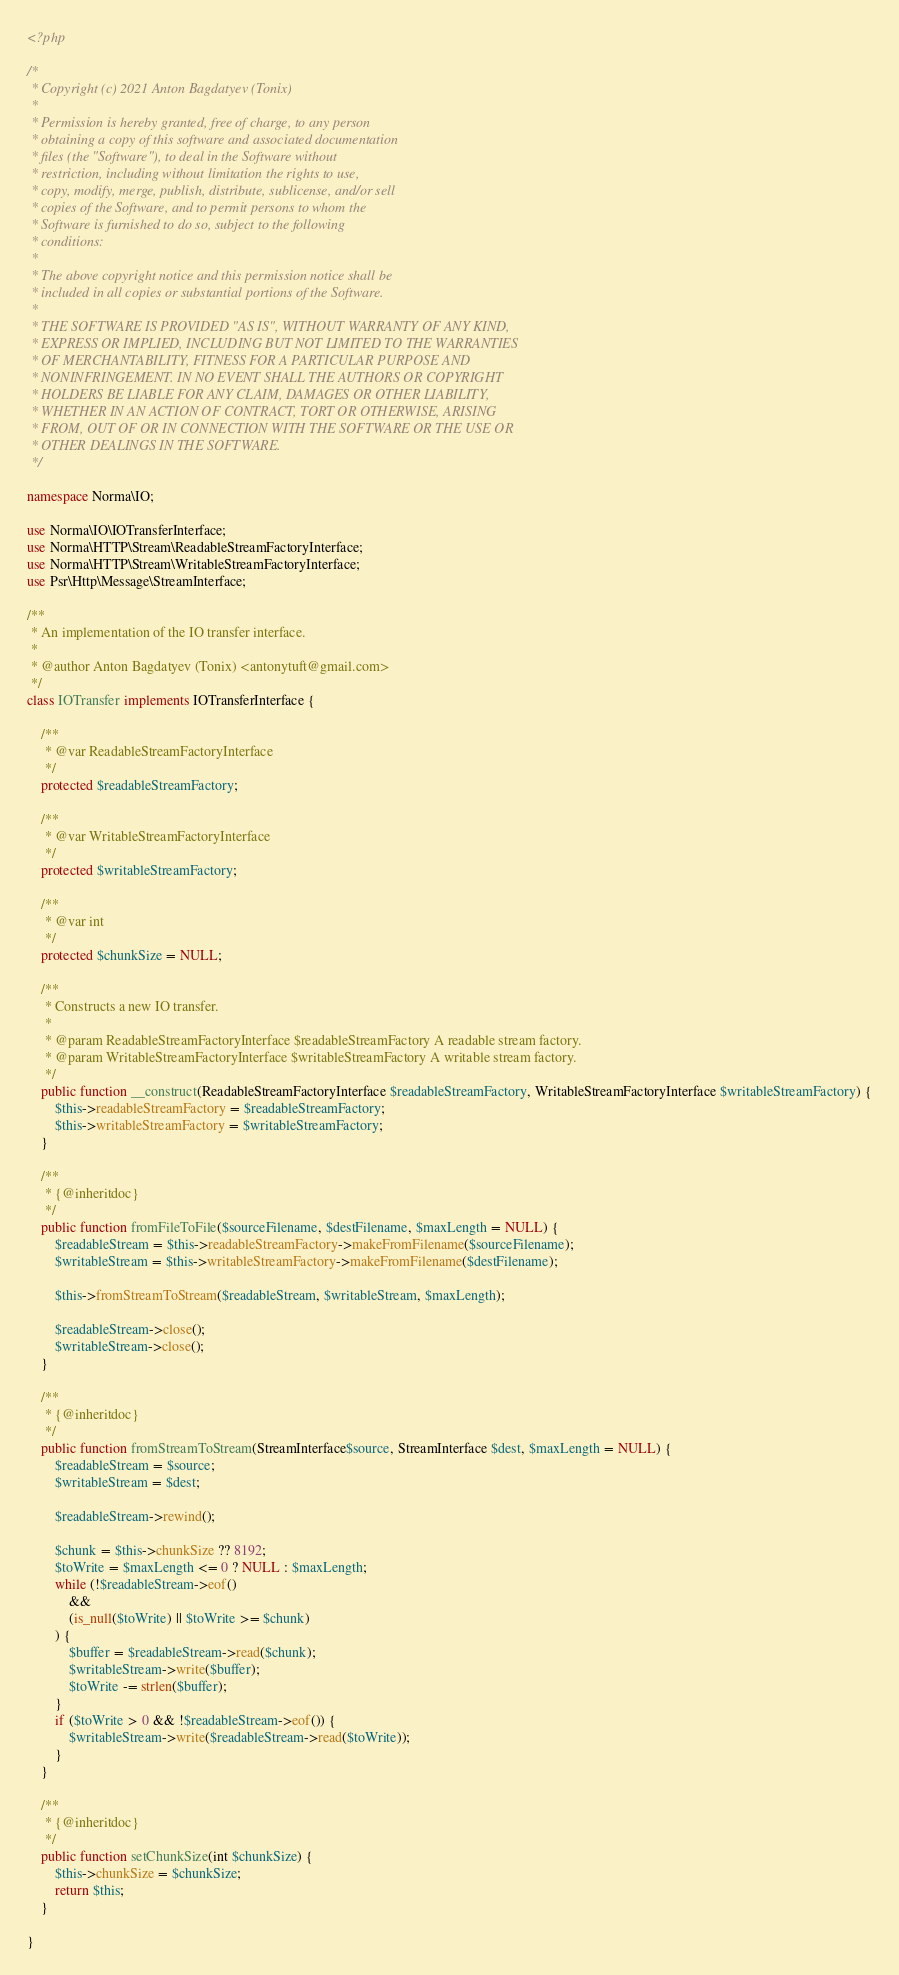<code> <loc_0><loc_0><loc_500><loc_500><_PHP_><?php

/*
 * Copyright (c) 2021 Anton Bagdatyev (Tonix)
 * 
 * Permission is hereby granted, free of charge, to any person
 * obtaining a copy of this software and associated documentation
 * files (the "Software"), to deal in the Software without
 * restriction, including without limitation the rights to use,
 * copy, modify, merge, publish, distribute, sublicense, and/or sell
 * copies of the Software, and to permit persons to whom the
 * Software is furnished to do so, subject to the following
 * conditions:
 * 
 * The above copyright notice and this permission notice shall be
 * included in all copies or substantial portions of the Software.
 * 
 * THE SOFTWARE IS PROVIDED "AS IS", WITHOUT WARRANTY OF ANY KIND,
 * EXPRESS OR IMPLIED, INCLUDING BUT NOT LIMITED TO THE WARRANTIES
 * OF MERCHANTABILITY, FITNESS FOR A PARTICULAR PURPOSE AND
 * NONINFRINGEMENT. IN NO EVENT SHALL THE AUTHORS OR COPYRIGHT
 * HOLDERS BE LIABLE FOR ANY CLAIM, DAMAGES OR OTHER LIABILITY,
 * WHETHER IN AN ACTION OF CONTRACT, TORT OR OTHERWISE, ARISING
 * FROM, OUT OF OR IN CONNECTION WITH THE SOFTWARE OR THE USE OR
 * OTHER DEALINGS IN THE SOFTWARE.
 */

namespace Norma\IO;

use Norma\IO\IOTransferInterface;
use Norma\HTTP\Stream\ReadableStreamFactoryInterface;
use Norma\HTTP\Stream\WritableStreamFactoryInterface;
use Psr\Http\Message\StreamInterface;

/**
 * An implementation of the IO transfer interface.
 *
 * @author Anton Bagdatyev (Tonix) <antonytuft@gmail.com>
 */
class IOTransfer implements IOTransferInterface {
    
    /**
     * @var ReadableStreamFactoryInterface
     */
    protected $readableStreamFactory;
    
    /**
     * @var WritableStreamFactoryInterface
     */
    protected $writableStreamFactory;
    
    /**
     * @var int
     */
    protected $chunkSize = NULL;
    
    /**
     * Constructs a new IO transfer.
     * 
     * @param ReadableStreamFactoryInterface $readableStreamFactory A readable stream factory.
     * @param WritableStreamFactoryInterface $writableStreamFactory A writable stream factory.
     */
    public function __construct(ReadableStreamFactoryInterface $readableStreamFactory, WritableStreamFactoryInterface $writableStreamFactory) {
        $this->readableStreamFactory = $readableStreamFactory;
        $this->writableStreamFactory = $writableStreamFactory;
    }
    
    /**
     * {@inheritdoc}
     */
    public function fromFileToFile($sourceFilename, $destFilename, $maxLength = NULL) {
        $readableStream = $this->readableStreamFactory->makeFromFilename($sourceFilename);
        $writableStream = $this->writableStreamFactory->makeFromFilename($destFilename);
        
        $this->fromStreamToStream($readableStream, $writableStream, $maxLength);
        
        $readableStream->close();
        $writableStream->close();
    }

    /**
     * {@inheritdoc}
     */
    public function fromStreamToStream(StreamInterface$source, StreamInterface $dest, $maxLength = NULL) {
        $readableStream = $source;
        $writableStream = $dest;
        
        $readableStream->rewind();
        
        $chunk = $this->chunkSize ?? 8192;
        $toWrite = $maxLength <= 0 ? NULL : $maxLength;
        while (!$readableStream->eof()
            && 
            (is_null($toWrite) || $toWrite >= $chunk)
        ) {
            $buffer = $readableStream->read($chunk);
            $writableStream->write($buffer);
            $toWrite -= strlen($buffer);
        }
        if ($toWrite > 0 && !$readableStream->eof()) {
            $writableStream->write($readableStream->read($toWrite));
        }
    }
    
    /**
     * {@inheritdoc}
     */
    public function setChunkSize(int $chunkSize) {
        $this->chunkSize = $chunkSize;
        return $this;
    }

}
</code> 